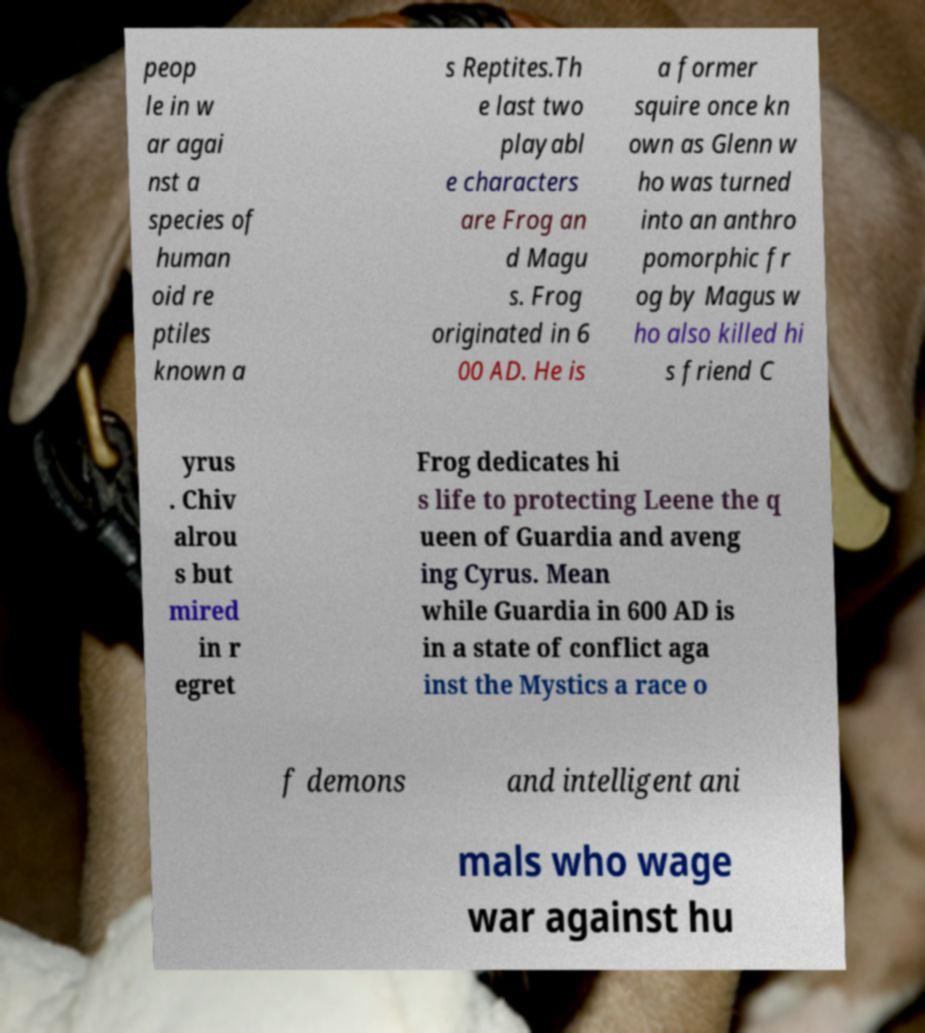Please read and relay the text visible in this image. What does it say? peop le in w ar agai nst a species of human oid re ptiles known a s Reptites.Th e last two playabl e characters are Frog an d Magu s. Frog originated in 6 00 AD. He is a former squire once kn own as Glenn w ho was turned into an anthro pomorphic fr og by Magus w ho also killed hi s friend C yrus . Chiv alrou s but mired in r egret Frog dedicates hi s life to protecting Leene the q ueen of Guardia and aveng ing Cyrus. Mean while Guardia in 600 AD is in a state of conflict aga inst the Mystics a race o f demons and intelligent ani mals who wage war against hu 